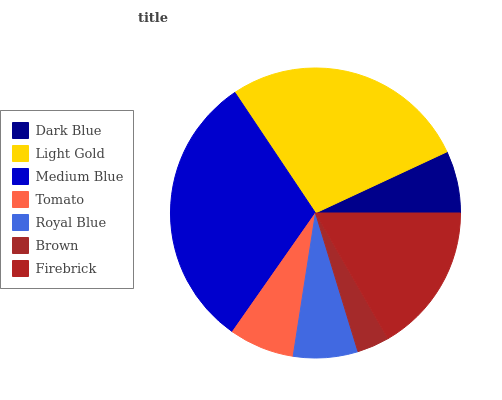Is Brown the minimum?
Answer yes or no. Yes. Is Medium Blue the maximum?
Answer yes or no. Yes. Is Light Gold the minimum?
Answer yes or no. No. Is Light Gold the maximum?
Answer yes or no. No. Is Light Gold greater than Dark Blue?
Answer yes or no. Yes. Is Dark Blue less than Light Gold?
Answer yes or no. Yes. Is Dark Blue greater than Light Gold?
Answer yes or no. No. Is Light Gold less than Dark Blue?
Answer yes or no. No. Is Tomato the high median?
Answer yes or no. Yes. Is Tomato the low median?
Answer yes or no. Yes. Is Medium Blue the high median?
Answer yes or no. No. Is Dark Blue the low median?
Answer yes or no. No. 